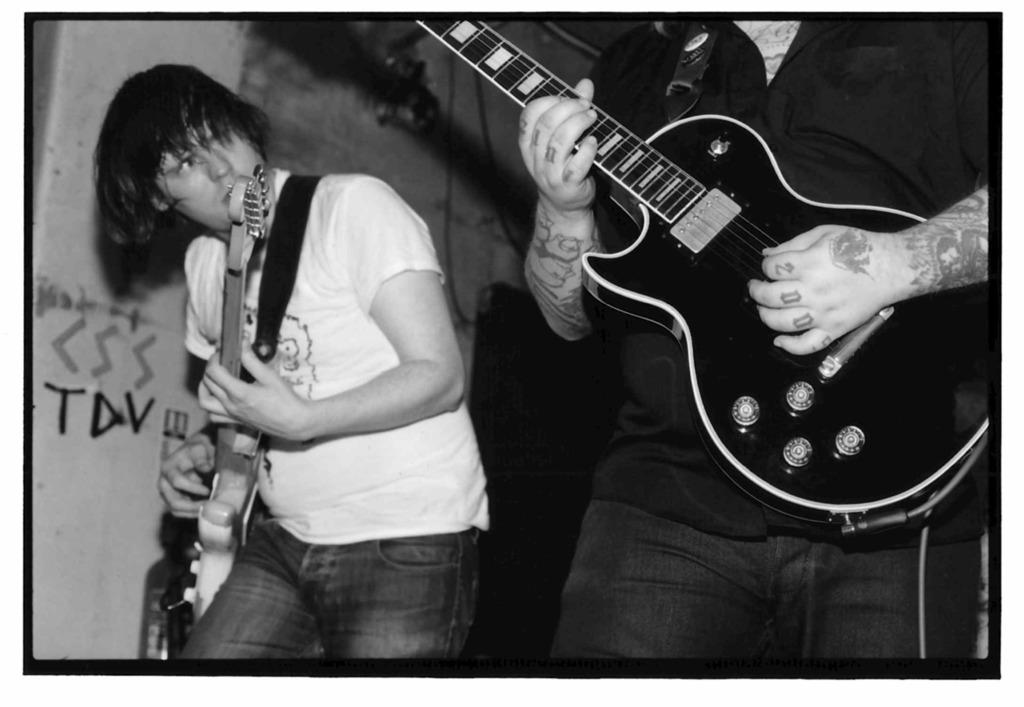What are the two people in the image doing? The two people in the image are playing guitars. Can you describe the clothing of the person on the left side of the image? The person on the left side is wearing a white t-shirt. What is visible in the background of the image? There is a wall in the background of the image. What type of farm animals can be seen in the image? There are no farm animals present in the image; it features two people playing guitars. Can you tell me how many twigs are being used as guitar picks in the image? There is no mention of twigs or guitar picks in the image; it only shows two people playing guitars. 